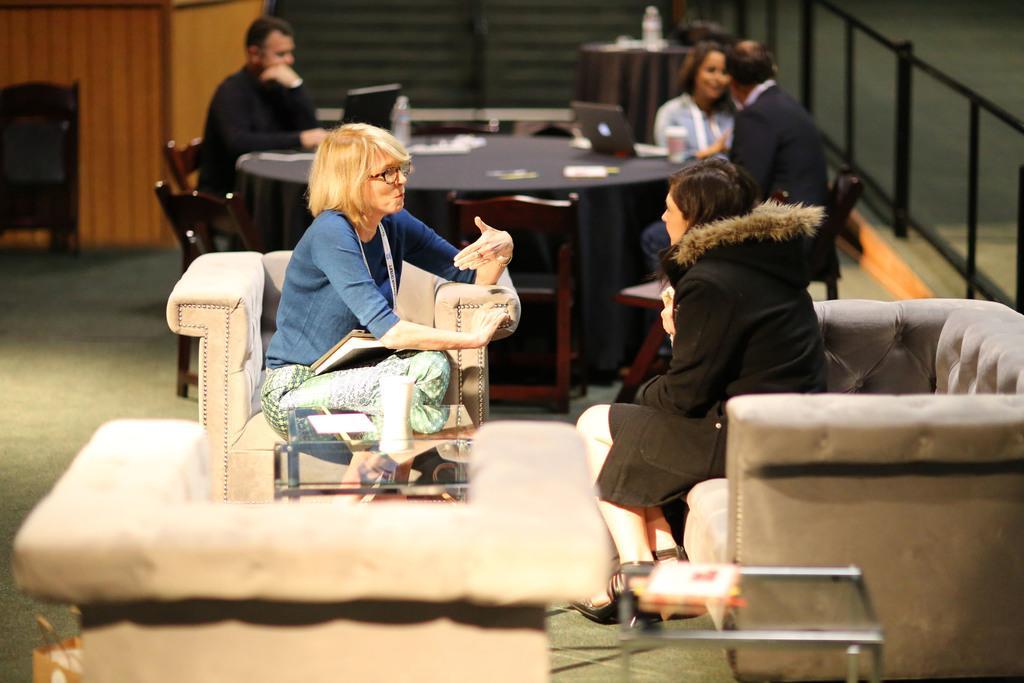Describe this image in one or two sentences. This image is taken indoors. In the background there is a wall. There is an empty chair and there is a table with a few things on it. On the right side of the image there is a railing. In the middle of the image two women are sitting on the couches and there is a table with a few things on it and there is an empty couch. Two men and a woman are sitting on the chairs and there is a table with a few things on it. 